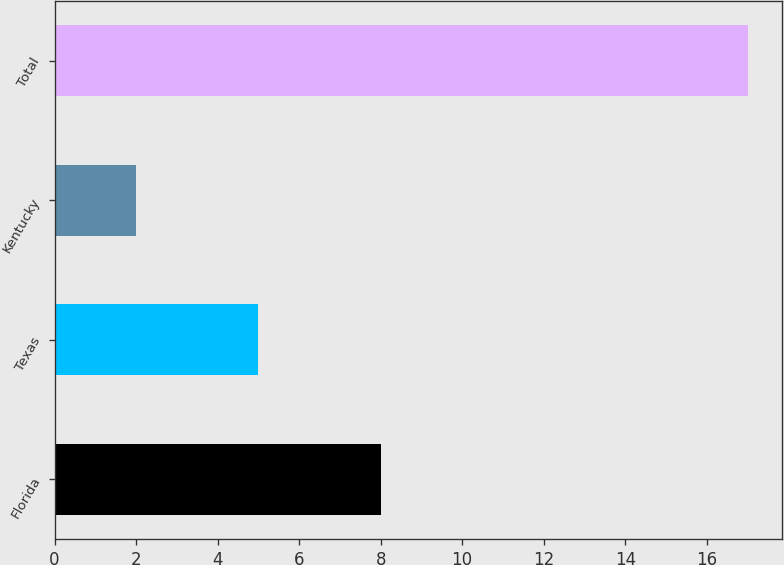Convert chart. <chart><loc_0><loc_0><loc_500><loc_500><bar_chart><fcel>Florida<fcel>Texas<fcel>Kentucky<fcel>Total<nl><fcel>8<fcel>5<fcel>2<fcel>17<nl></chart> 